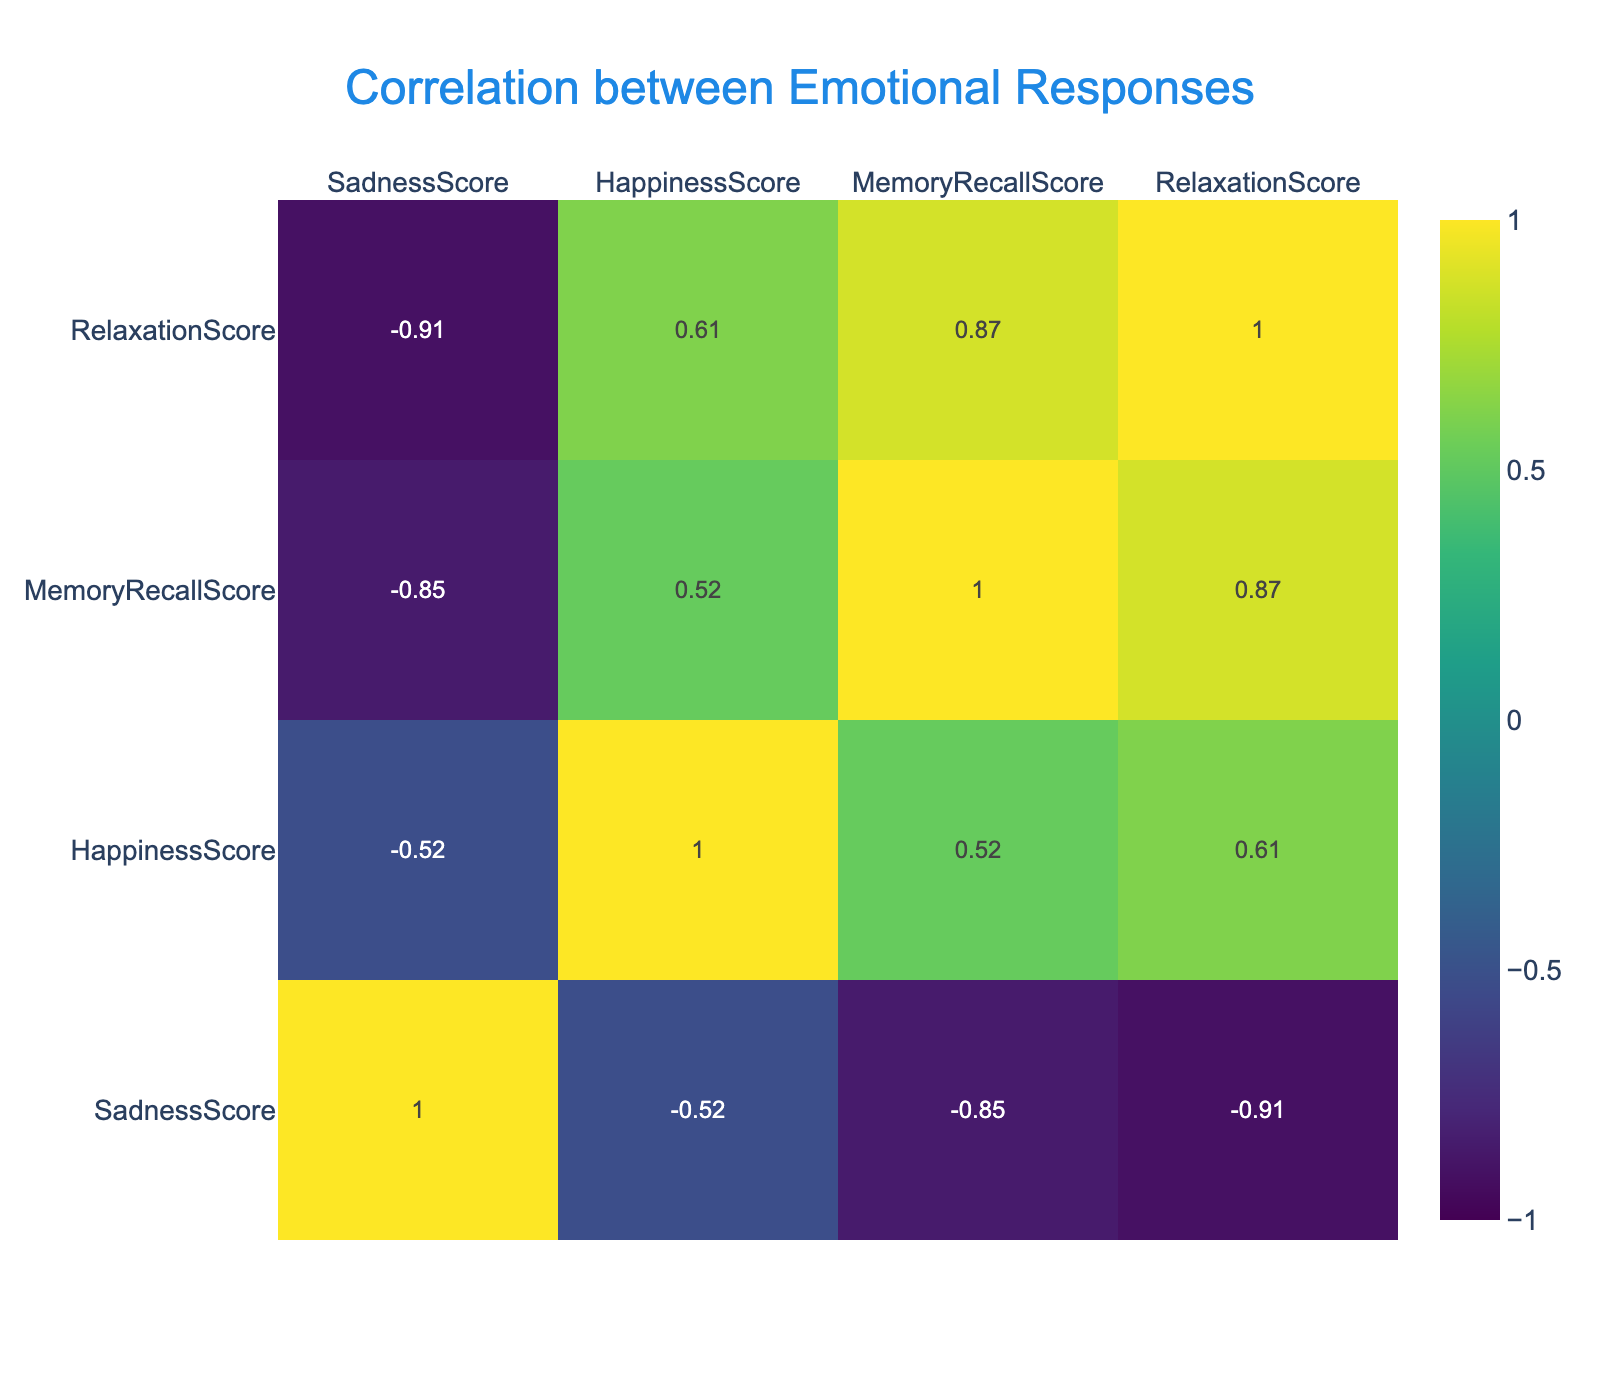What is the correlation between Happiness Score and Relaxation Score? Looking at the table, the correlation value for Happiness Score and Relaxation Score is 0.66. This indicates a moderate positive correlation, meaning that as the Happiness Score increases, so does the Relaxation Score.
Answer: 0.66 Which music type has the highest Happiness Score? By examining the Happiness Scores in the table, Gospel has the highest score of 9.
Answer: Gospel What is the average Sadness Score across all music types? To find the average Sadness Score, sum all Sadness Scores (2 + 3 + 5 + 6 + 4 + 4 + 2 + 3 + 4 + 2) = 35. Then divide by the number of music types (10). Therefore, the average is 35/10 = 3.5.
Answer: 3.5 Is there a higher correlation between Memory Recall Score and Relaxation Score than between Sadness Score and Happiness Score? The correlation between Memory Recall Score and Relaxation Score is 0.62, while the correlation between Sadness Score and Happiness Score is -0.41. Since 0.62 is greater than -0.41, the answer is yes.
Answer: Yes What is the difference in Happiness Scores between Classical and Blues music? The Happiness Score for Classical music is 8, and for Blues music, it is 4. The difference is calculated as 8 - 4 = 4.
Answer: 4 Which music type has the lowest Relaxation Score? By checking the Relaxation Scores, Rock music has the lowest score of 5.
Answer: Rock What is the overall correlation trend between Sadness Score and Happiness Score? The correlation between Sadness Score and Happiness Score is -0.79, indicating a strong negative correlation. This means that as the Sadness Score increases, the Happiness Score tends to decrease.
Answer: Strong negative correlation What music types are associated with a Happiness Score above 8? The music types associated with a Happiness Score above 8 are Classical and Gospel, with scores of 8 and 9, respectively.
Answer: Classical, Gospel 